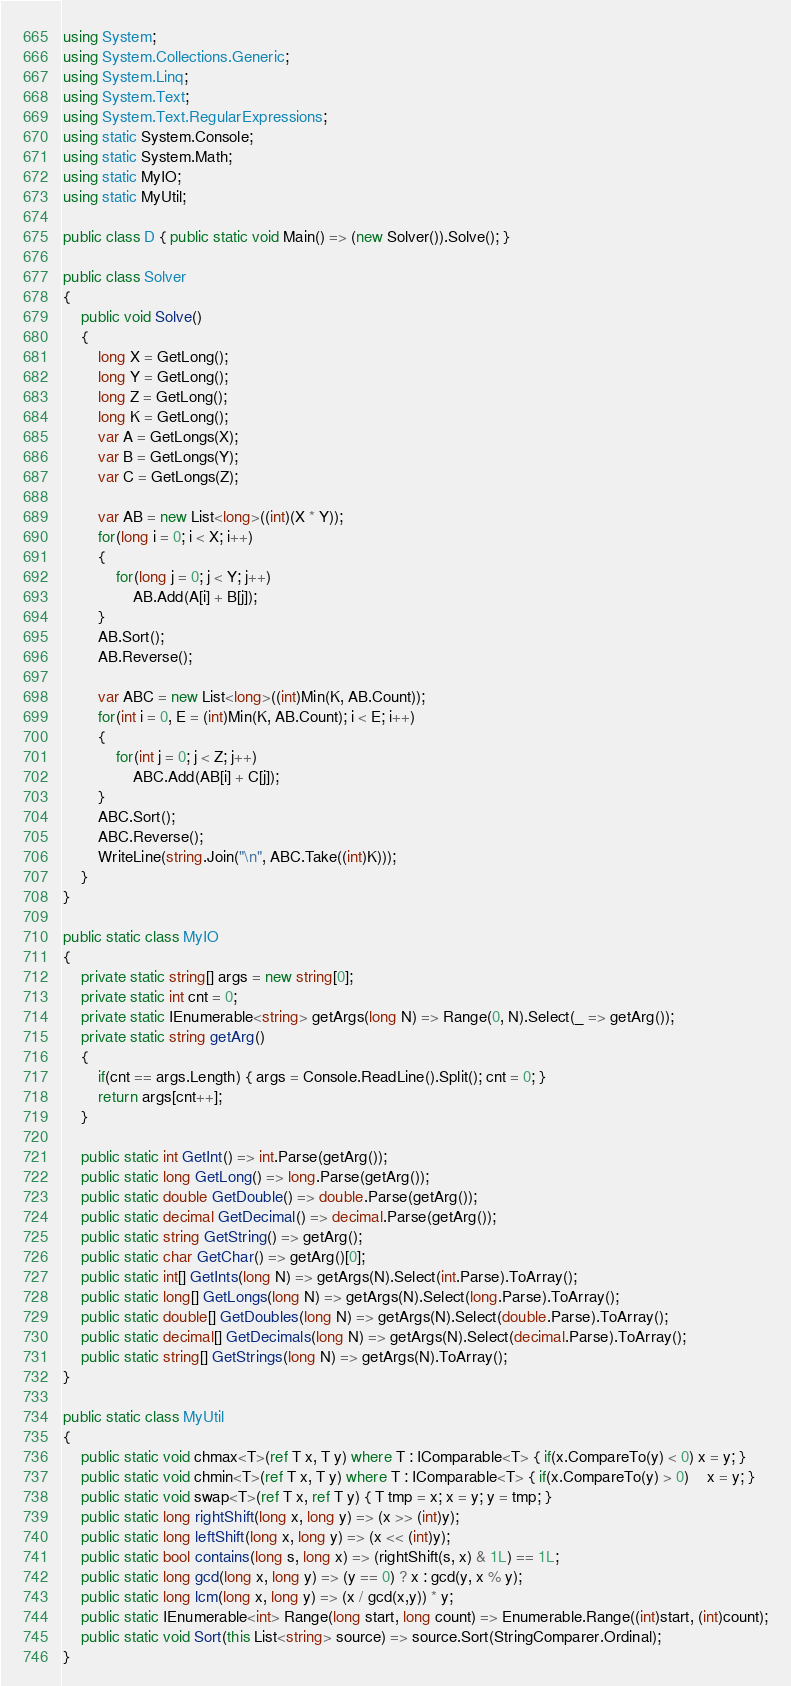Convert code to text. <code><loc_0><loc_0><loc_500><loc_500><_C#_>using System;
using System.Collections.Generic;
using System.Linq;
using System.Text;
using System.Text.RegularExpressions;
using static System.Console;
using static System.Math;
using static MyIO;
using static MyUtil;

public class D { public static void Main() => (new Solver()).Solve(); }

public class Solver
{
	public void Solve()
	{
		long X = GetLong();
		long Y = GetLong();
		long Z = GetLong();
		long K = GetLong();
		var A = GetLongs(X);
		var B = GetLongs(Y);
		var C = GetLongs(Z);

		var AB = new List<long>((int)(X * Y));
		for(long i = 0; i < X; i++)
		{
			for(long j = 0; j < Y; j++)
				AB.Add(A[i] + B[j]);
		}
		AB.Sort();
		AB.Reverse();

		var ABC = new List<long>((int)Min(K, AB.Count));
		for(int i = 0, E = (int)Min(K, AB.Count); i < E; i++)
		{
			for(int j = 0; j < Z; j++)
				ABC.Add(AB[i] + C[j]);
		}
		ABC.Sort();
		ABC.Reverse();
		WriteLine(string.Join("\n", ABC.Take((int)K)));
	}
}

public static class MyIO
{
	private static string[] args = new string[0];
	private static int cnt = 0;
	private static IEnumerable<string> getArgs(long N) => Range(0, N).Select(_ => getArg());
	private static string getArg()
	{
		if(cnt == args.Length) { args = Console.ReadLine().Split(); cnt = 0; }
		return args[cnt++];
	}

	public static int GetInt() => int.Parse(getArg());
	public static long GetLong() => long.Parse(getArg());
	public static double GetDouble() => double.Parse(getArg());
	public static decimal GetDecimal() => decimal.Parse(getArg());
	public static string GetString() => getArg();
	public static char GetChar() => getArg()[0];
	public static int[] GetInts(long N) => getArgs(N).Select(int.Parse).ToArray();
	public static long[] GetLongs(long N) => getArgs(N).Select(long.Parse).ToArray();
	public static double[] GetDoubles(long N) => getArgs(N).Select(double.Parse).ToArray();
	public static decimal[] GetDecimals(long N) => getArgs(N).Select(decimal.Parse).ToArray();
	public static string[] GetStrings(long N) => getArgs(N).ToArray();
}

public static class MyUtil
{
	public static void chmax<T>(ref T x, T y) where T : IComparable<T> { if(x.CompareTo(y) < 0) x = y; }
	public static void chmin<T>(ref T x, T y) where T : IComparable<T> { if(x.CompareTo(y) > 0)	x = y; }
	public static void swap<T>(ref T x, ref T y) { T tmp = x; x = y; y = tmp; }
	public static long rightShift(long x, long y) => (x >> (int)y);
	public static long leftShift(long x, long y) => (x << (int)y);
	public static bool contains(long s, long x) => (rightShift(s, x) & 1L) == 1L;
	public static long gcd(long x, long y) => (y == 0) ? x : gcd(y, x % y);
	public static long lcm(long x, long y) => (x / gcd(x,y)) * y;	
	public static IEnumerable<int> Range(long start, long count) => Enumerable.Range((int)start, (int)count);
	public static void Sort(this List<string> source) => source.Sort(StringComparer.Ordinal);
}
</code> 